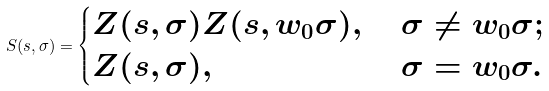Convert formula to latex. <formula><loc_0><loc_0><loc_500><loc_500>S ( s , \sigma ) = \begin{cases} Z ( s , \sigma ) Z ( s , w _ { 0 } \sigma ) , & \ \sigma \neq w _ { 0 } \sigma ; \\ Z ( s , \sigma ) , & \ \sigma = w _ { 0 } \sigma . \end{cases}</formula> 